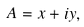Convert formula to latex. <formula><loc_0><loc_0><loc_500><loc_500>A = x + i y ,</formula> 